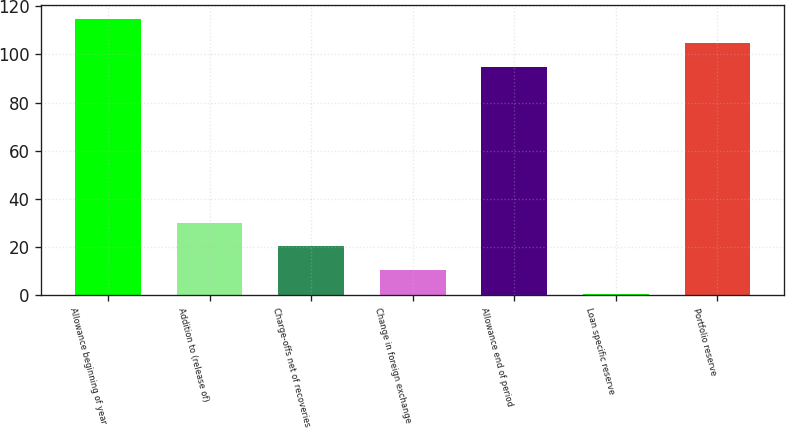<chart> <loc_0><loc_0><loc_500><loc_500><bar_chart><fcel>Allowance beginning of year<fcel>Addition to (release of)<fcel>Charge-offs net of recoveries<fcel>Change in foreign exchange<fcel>Allowance end of period<fcel>Loan specific reserve<fcel>Portfolio reserve<nl><fcel>114.66<fcel>30.23<fcel>20.41<fcel>10.58<fcel>95<fcel>0.75<fcel>104.83<nl></chart> 